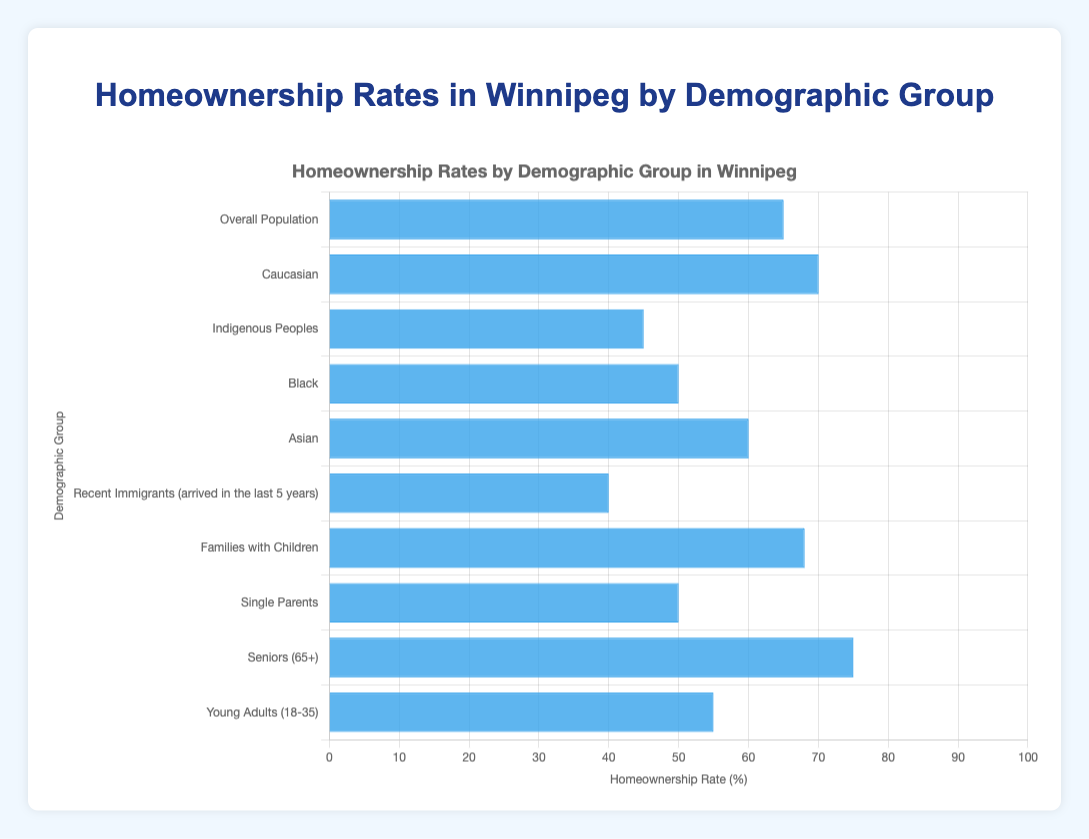Which demographic group has the highest homeownership rate? By observing the length of the bars in the chart, the group with the longest bar representing the highest rate can be seen.
Answer: Seniors (65+) Which groups have a homeownership rate lower than the overall population? The overall population's homeownership rate is 65%. Comparing all groups to this value, we can identify which ones fall below. Indigenous Peoples (45%), Black (50%), Recent Immigrants (40%), Single Parents (50%), and Young Adults (55%) have lower rates.
Answer: Indigenous Peoples, Black, Recent Immigrants, Single Parents, Young Adults What is the difference in homeownership rates between Caucasians and Indigenous Peoples? The homeownership rate for Caucasians is 70% and for Indigenous Peoples is 45%. Subtracting these values gives the difference.
Answer: 25% What demographic group has a similar homeownership rate to Young Adults? By visually comparing the bar representing Young Adults (55%) to others, the bar for the Black group (50%) appears to be closest.
Answer: Black What is the combined homeownership rate for Indigenous Peoples, Black, and Recent Immigrants? Sum the homeownership rates of these three groups: 45% (Indigenous Peoples) + 50% (Black) + 40% (Recent Immigrants) = 135%
Answer: 135% Which two groups show the biggest contrast in homeownership rates? The largest difference is sought. Seniors (75%) and Recent Immigrants (40%) display the highest contrast by a difference of 35%.
Answer: Seniors and Recent Immigrants Compare the homeownership rates for Families with Children and Single Parents. By comparing the length of the bars, Families with Children have 68% and Single Parents have 50%. Thus, Families with Children have a higher rate.
Answer: Families with Children What is the average homeownership rate of the Indigenous Peoples, Black, and Single Parents groups? First, sum the rates: 45% (Indigenous Peoples) + 50% (Black) + 50% (Single Parents) = 145%. Then divide by the number of groups: 145% / 3 ≈ 48.33%.
Answer: 48.33% What percentage of difference is there between the homeownership rates of Seniors and the overall population? Seniors have 75% and the overall population has 65%. The difference is 75% - 65% = 10%, which is a direct subtraction.
Answer: 10% Which demographic group shows a homeownership rate just below the overall average? Referring to the chart, the overall population's rate is 65%. The group with a similar but slightly lower rate is Asians at 60%.
Answer: Asians 